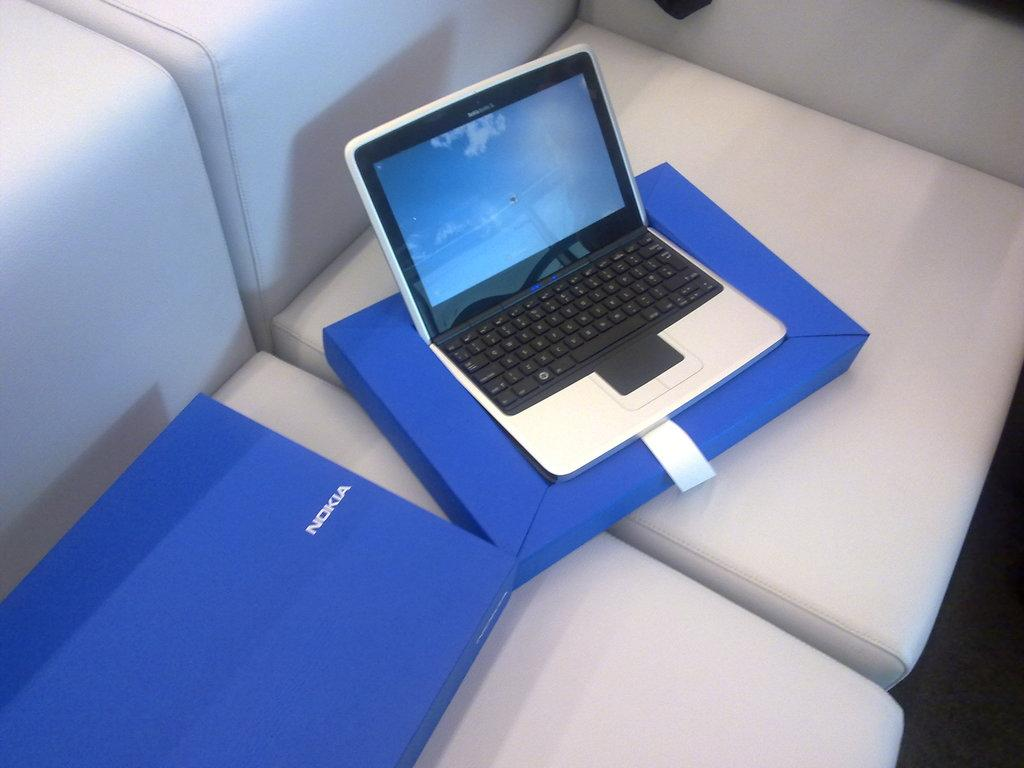<image>
Give a short and clear explanation of the subsequent image. Nokia laptop sitting on top of a blue Nokia box. 